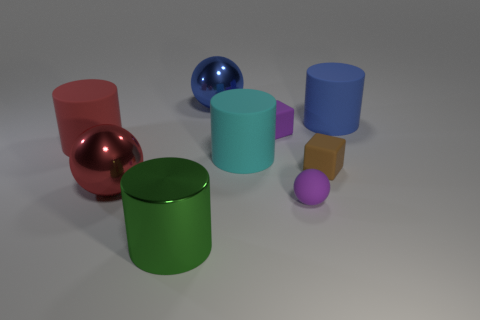There is a purple object that is in front of the brown thing; is its shape the same as the big cyan thing?
Provide a succinct answer. No. Are any big green matte blocks visible?
Give a very brief answer. No. There is a large rubber cylinder behind the small purple block behind the large red thing in front of the red matte thing; what is its color?
Give a very brief answer. Blue. Are there an equal number of tiny brown objects that are on the left side of the large green thing and objects right of the brown thing?
Your answer should be compact. No. What is the shape of the blue rubber thing that is the same size as the green cylinder?
Provide a succinct answer. Cylinder. Are there any tiny rubber cubes of the same color as the tiny rubber ball?
Provide a succinct answer. Yes. What is the shape of the large rubber object that is behind the purple cube?
Ensure brevity in your answer.  Cylinder. The big metal cylinder is what color?
Your answer should be compact. Green. The other big ball that is made of the same material as the large red ball is what color?
Offer a terse response. Blue. What number of green cylinders are the same material as the large blue ball?
Ensure brevity in your answer.  1. 